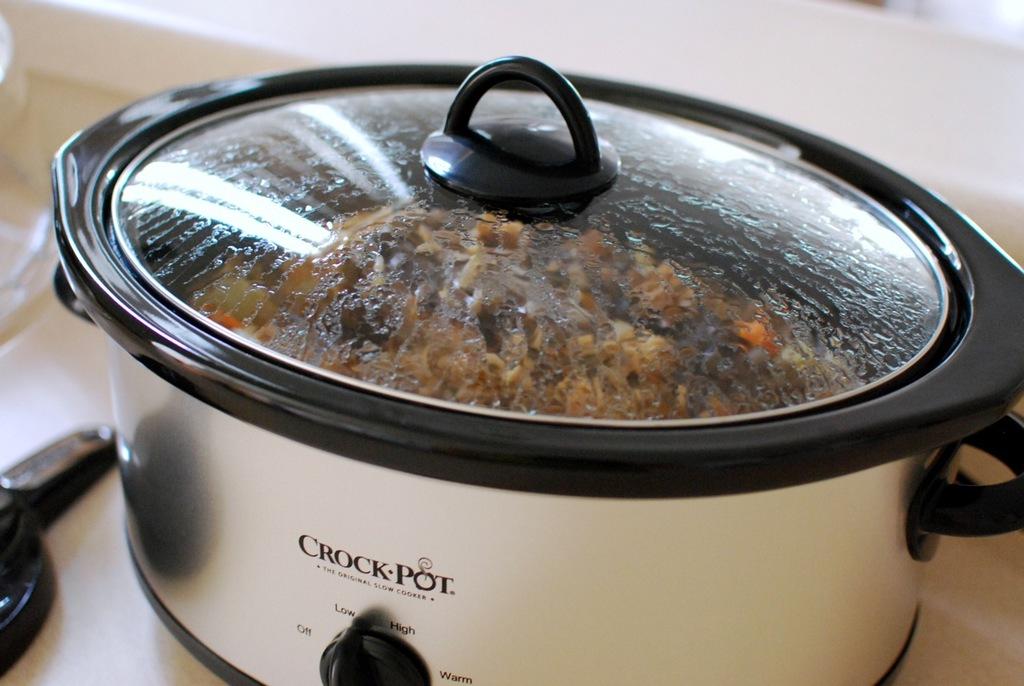What level is the crockpot set at?
Your response must be concise. Low. 